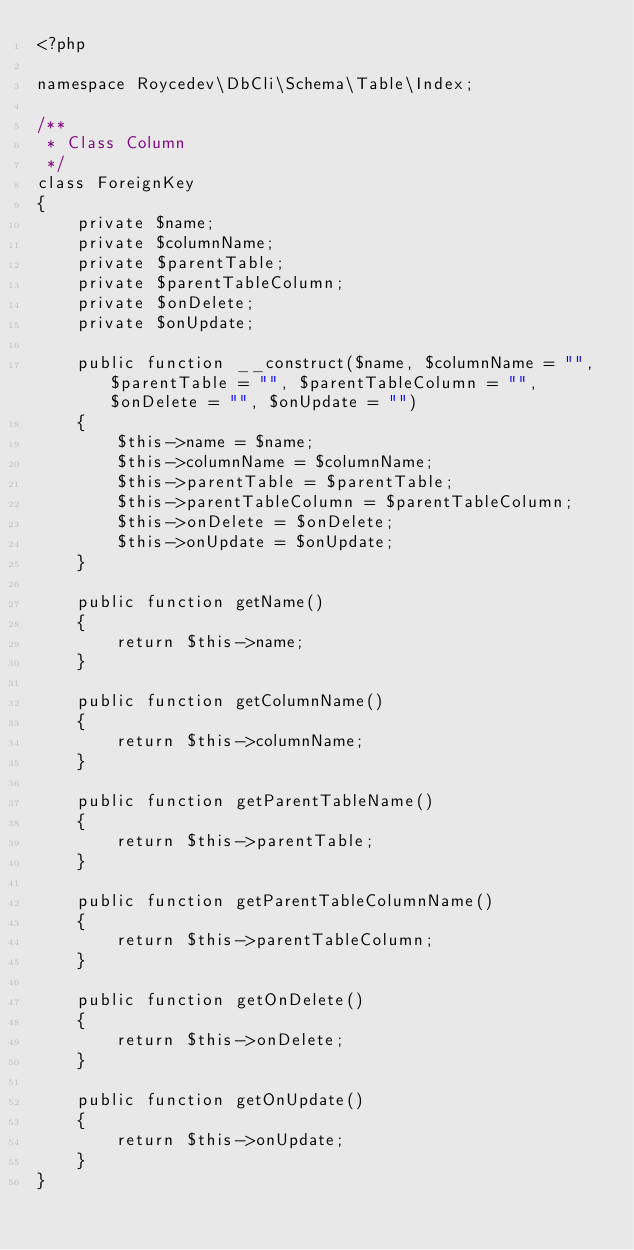<code> <loc_0><loc_0><loc_500><loc_500><_PHP_><?php

namespace Roycedev\DbCli\Schema\Table\Index;

/**
 * Class Column
 */
class ForeignKey
{
    private $name;
    private $columnName;
    private $parentTable;
    private $parentTableColumn;
    private $onDelete;
    private $onUpdate;

    public function __construct($name, $columnName = "", $parentTable = "", $parentTableColumn = "", $onDelete = "", $onUpdate = "")
    {
        $this->name = $name;
        $this->columnName = $columnName;
        $this->parentTable = $parentTable;
        $this->parentTableColumn = $parentTableColumn;
        $this->onDelete = $onDelete;
        $this->onUpdate = $onUpdate;
    }

    public function getName()
    {
        return $this->name;
    }

    public function getColumnName()
    {
        return $this->columnName;
    }

    public function getParentTableName()
    {
        return $this->parentTable;
    }

    public function getParentTableColumnName()
    {
        return $this->parentTableColumn;
    }

    public function getOnDelete()
    {
        return $this->onDelete;
    }

    public function getOnUpdate()
    {
        return $this->onUpdate;
    }
}
</code> 